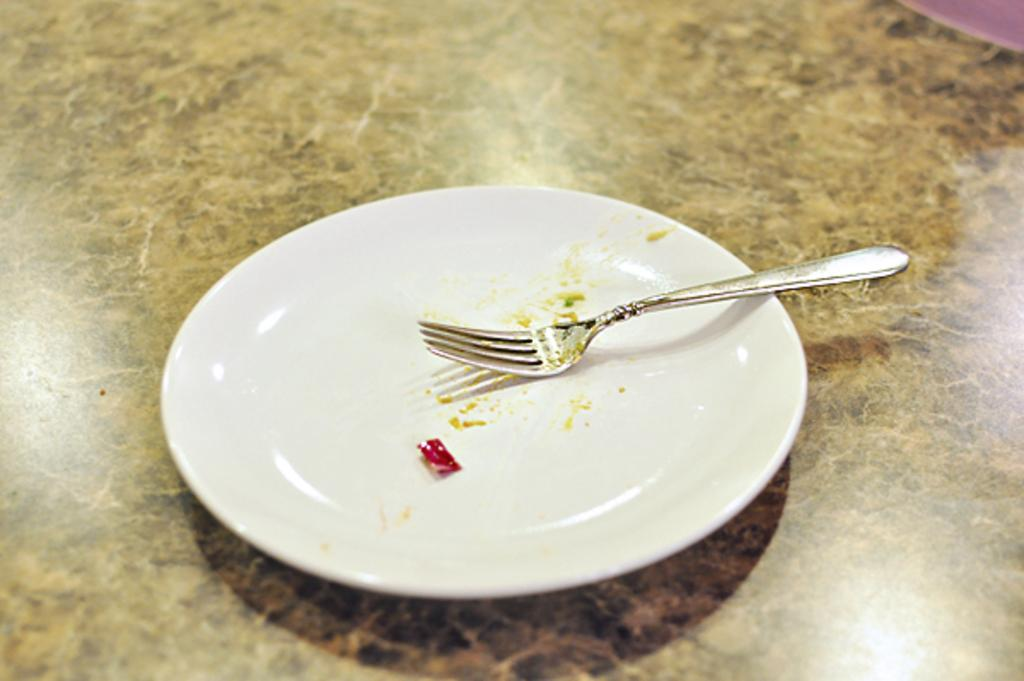What color is the plate in the image? The plate in the image is white. What utensil is placed on the plate? There is a fork placed in the plate. What is the color of the surface on which the plate is placed? The plate is placed on a brown color surface. What time does the clock show in the image? There is no clock present in the image. What type of cloud can be seen in the image? There are no clouds present in the image. 